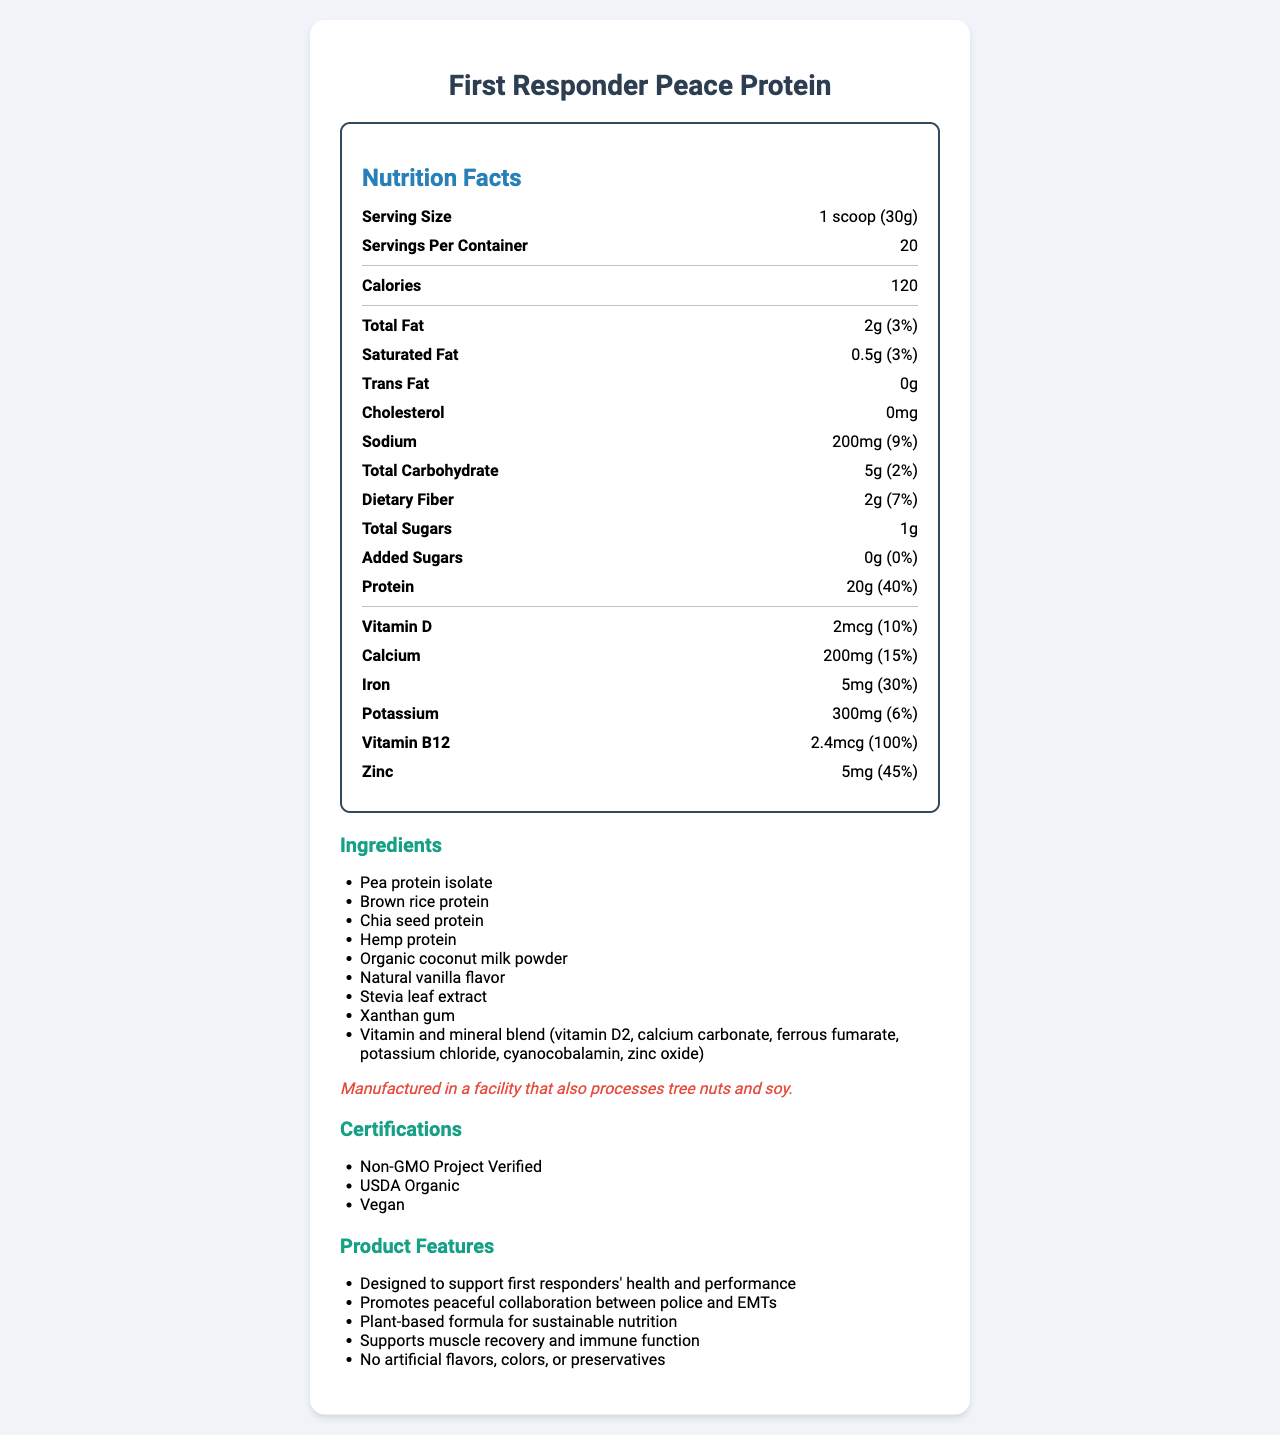what is the serving size of the First Responder Peace Protein? The serving size is clearly listed at the top of the Nutrition Facts section as 1 scoop (30g).
Answer: 1 scoop (30g) How many calories are there per serving? The number of calories per serving is listed under the Calories section, which is 120.
Answer: 120 What percentage of daily value does 20g of protein represent? According to the document, 20g of protein provides 40% of the daily value.
Answer: 40% What is the amount of sodium per serving, and what percentage of the daily value does this represent? The sodium content per serving is 200mg and it represents 9% of the daily value, as listed in the sodium section.
Answer: 200mg, 9% List three ingredients in the First Responder Peace Protein? The ingredients section lists these and other ingredients, with Pea protein isolate, Brown rice protein, and Chia seed protein being three of them.
Answer: Pea protein isolate, Brown rice protein, Chia seed protein How much dietary fiber does one serving provide? The dietary fiber content per serving is listed as 2g in the Nutrition Facts.
Answer: 2g What is the cholesterol content in this product? The cholesterol content is 0mg as indicated in the document.
Answer: 0mg How many servings are there per container? A. 10 B. 15 C. 20 D. 25 The document states that there are 20 servings per container.
Answer: C Which of the following nutrients has the highest daily value percentage? A. Fiber B. Protein C. Vitamin B12 D. Vitamin D Vitamin B12 has the highest daily value percentage at 100%, followed by Protein at 40%, Iron at 30%, and Fiber at 7%.
Answer: C Is this product certified as Vegan? The certifications section lists that the product is Vegan among other certifications.
Answer: Yes Summarize the main claims and attributes of the First Responder Peace Protein. The document highlights this shake as an ideal choice for first responders due to its nutritional benefits and plant-based nature. Key ingredients and no artificial additives are emphasized along with multiple organic and vegan certifications.
Answer: The First Responder Peace Protein is a plant-based protein shake designed for the health and performance of first responders. It supports peaceful collaboration between police and EMTs and includes ingredients such as Pea protein isolate and Brown rice protein. It's vegan, non-GMO, and USDA organic. The shake provides 20g of protein per serving along with other vitamins and minerals with no artificial flavors, colors, or preservatives. What is the daily value percentage of potassium in one serving? The potassium content is 300mg per serving and represents 6% of the daily value according to the document.
Answer: 6% What facility process allergens are mentioned? The allergen information section notes that the product is manufactured in a facility that also processes tree nuts and soy.
Answer: Tree nuts and soy Can the document tell us how long the First Responder Peace Protein has been on the market? The document does not provide any information regarding how long the product has been on the market.
Answer: Not enough information 